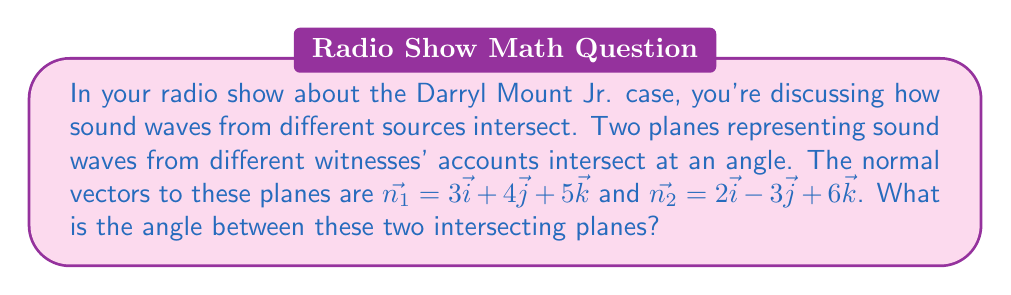Give your solution to this math problem. To find the angle between two intersecting planes, we can use the dot product of their normal vectors. The formula for the angle $\theta$ between two planes with normal vectors $\vec{n_1}$ and $\vec{n_2}$ is:

$$\cos \theta = \frac{|\vec{n_1} \cdot \vec{n_2}|}{|\vec{n_1}| |\vec{n_2}|}$$

Let's solve this step by step:

1) First, calculate the dot product $\vec{n_1} \cdot \vec{n_2}$:
   $$\vec{n_1} \cdot \vec{n_2} = (3)(2) + (4)(-3) + (5)(6) = 6 - 12 + 30 = 24$$

2) Calculate the magnitudes of $\vec{n_1}$ and $\vec{n_2}$:
   $$|\vec{n_1}| = \sqrt{3^2 + 4^2 + 5^2} = \sqrt{9 + 16 + 25} = \sqrt{50}$$
   $$|\vec{n_2}| = \sqrt{2^2 + (-3)^2 + 6^2} = \sqrt{4 + 9 + 36} = \sqrt{49} = 7$$

3) Now, substitute these values into the formula:
   $$\cos \theta = \frac{|24|}{\sqrt{50} \cdot 7} = \frac{24}{\sqrt{50} \cdot 7}$$

4) Simplify:
   $$\cos \theta = \frac{24}{7\sqrt{50}} = \frac{24\sqrt{2}}{70}$$

5) To find $\theta$, take the inverse cosine (arccos) of both sides:
   $$\theta = \arccos(\frac{24\sqrt{2}}{70})$$

6) Using a calculator, we can evaluate this:
   $$\theta \approx 0.7054 \text{ radians}$$

7) Convert to degrees:
   $$\theta \approx 0.7054 \cdot \frac{180}{\pi} \approx 40.40°$$
Answer: The angle between the two intersecting planes is approximately 40.40°. 